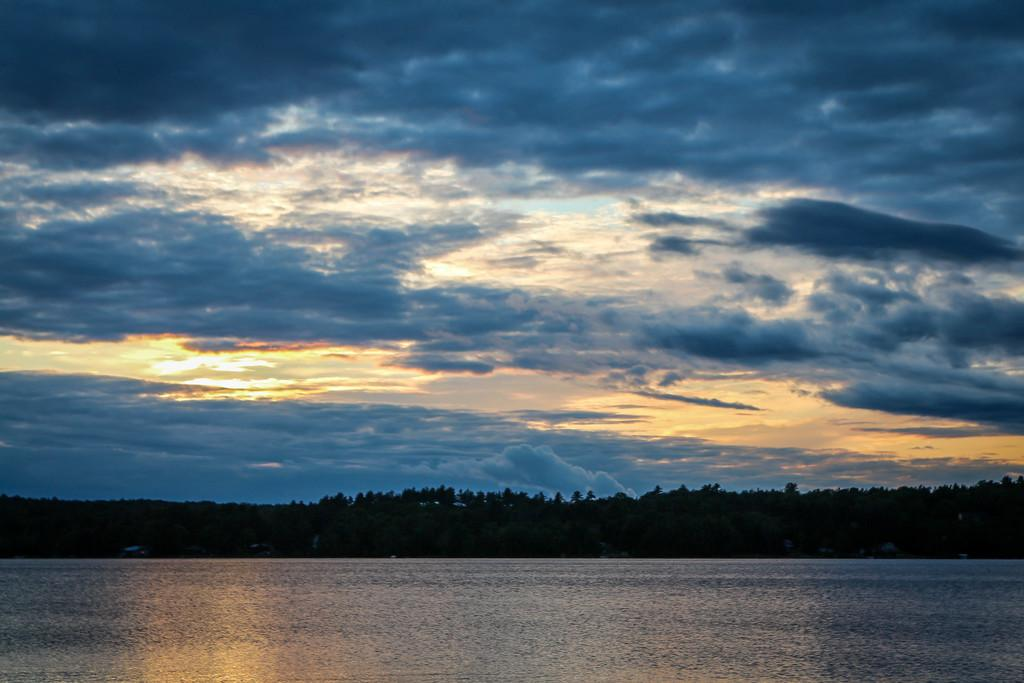What is the primary element visible in the image? There is water in the image. What can be seen in the distance behind the water? There are trees in the background of the image. What is the condition of the sky in the image? The sky is cloudy and visible at the top of the image. How many art pieces can be seen hanging on the trees in the image? There are no art pieces visible in the image; it features water, trees, and a cloudy sky. 